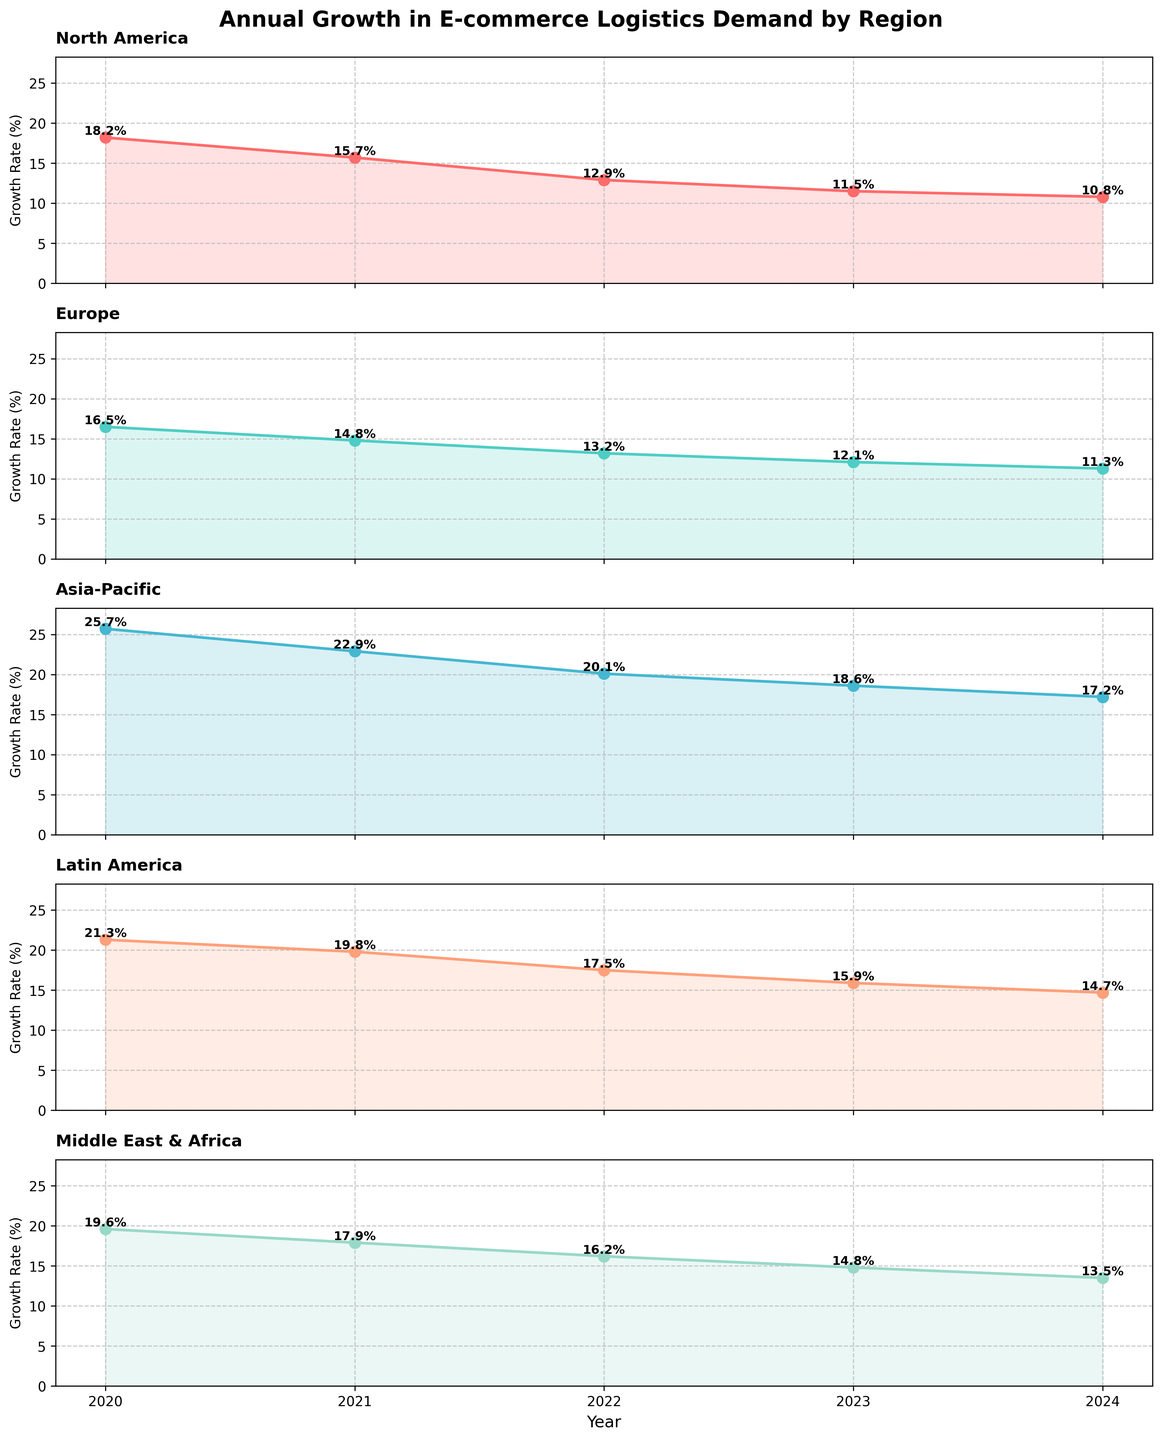Which region has the highest growth rate in 2020? By observing the top data point for each subplot, the Asia-Pacific region has the highest growth rate in 2020.
Answer: Asia-Pacific Which region saw the smallest decrease in growth rate from 2020 to 2021? To find this, check the difference between the 2020 and 2021 growth rates for each region. The smallest decrease is observed in the Europe region (16.5% to 14.8%, which is a 1.7% decrease).
Answer: Europe What is the overall trend in e-commerce logistics demand growth rates across all regions from 2020 to 2024? The trend across all regions shows a continuous decline in growth rates from 2020 to 2024.
Answer: Decline How does the growth rate of North America in 2024 compare to that of Latin America in 2022? The growth rate of North America in 2024 is 10.8%. The growth rate of Latin America in 2022 is 17.5%. Comparing these, North America's rate in 2024 is lower.
Answer: Lower Calculate the average growth rate for the Middle East & Africa from 2020 to 2024. Sum the growth rates for each year (19.6 + 17.9 + 16.2 + 14.8 + 13.5) = 82, then divide by the number of years (5), giving an average of 82/5 = 16.4%.
Answer: 16.4% Which region has the closest growth rate values in the years 2023 and 2024? Compare the growth rates in 2023 and 2024 for all regions. Europe shows the closest values, with 12.1% in 2023 and 11.3% in 2024, a difference of 0.8%.
Answer: Europe What is the difference in growth rates between the highest and lowest regions in 2023? The highest growth rate in 2023 is Asia-Pacific (18.6%) and the lowest is North America (11.5%). The difference is 18.6% - 11.5% = 7.1%.
Answer: 7.1% Which region shows a consistent year-on-year percentage decrease from 2020 to 2024? Checking the plotted values, all regions show a year-on-year decrease, but for a consistent percentage decrease, Asia-Pacific decreases by roughly the same range each year.
Answer: Asia-Pacific If you were to rank the regions by their growth rates in 2022, what would be the order from highest to lowest? The growth rates in 2022 from the figure are: Asia-Pacific (20.1%), Latin America (17.5%), Middle East & Africa (16.2%), Europe (13.2%), and North America (12.9%).
Answer: Asia-Pacific, Latin America, Middle East & Africa, Europe, North America Which region shows the greatest rate of declining growth rates over the years 2020 to 2024? Calculate the total decline by subtracting the 2024 rate from the 2020 rate for each region and identify the highest difference. Asia-Pacific declines from 25.7% to 17.2%, a total decline of 8.5%, the greatest decline among the regions.
Answer: Asia-Pacific 